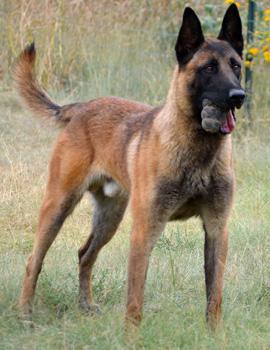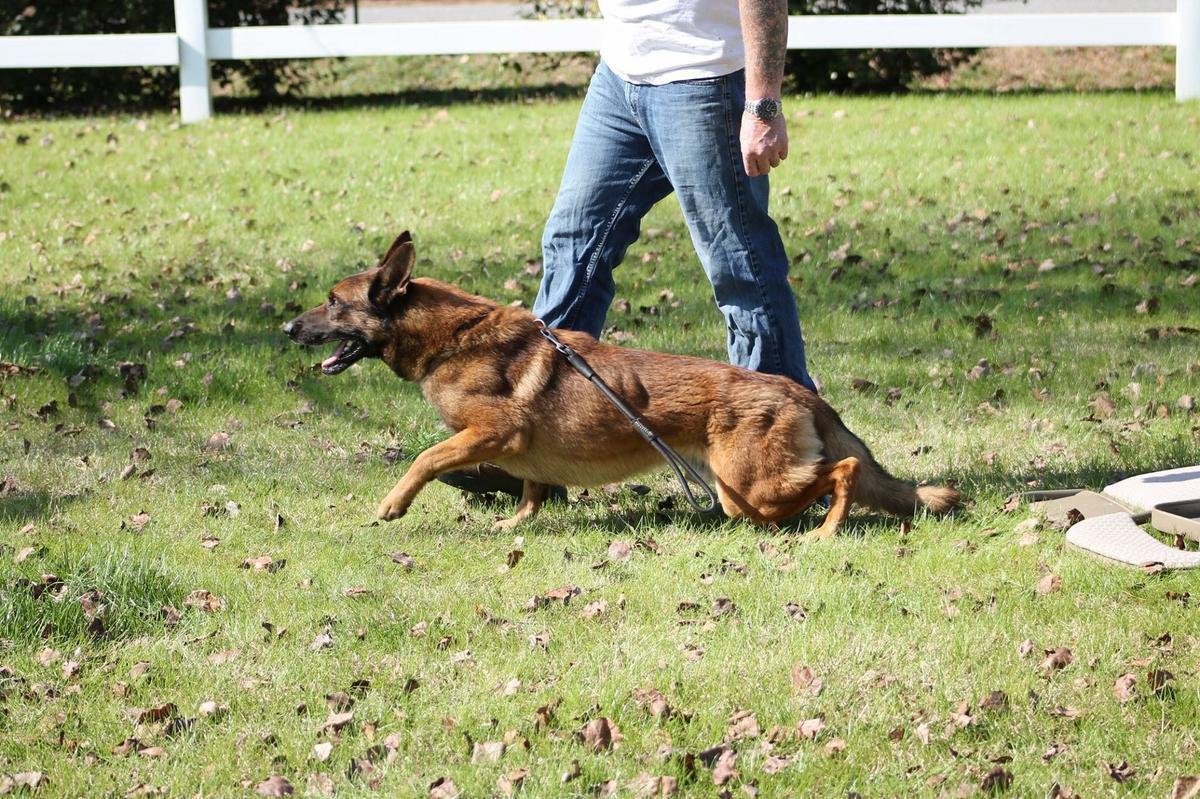The first image is the image on the left, the second image is the image on the right. For the images shown, is this caption "At least one dog has a leash attached, and at least one dog has an open, non-snarling mouth." true? Answer yes or no. Yes. The first image is the image on the left, the second image is the image on the right. Analyze the images presented: Is the assertion "One of the dogs is sitting down & looking towards the camera." valid? Answer yes or no. No. 